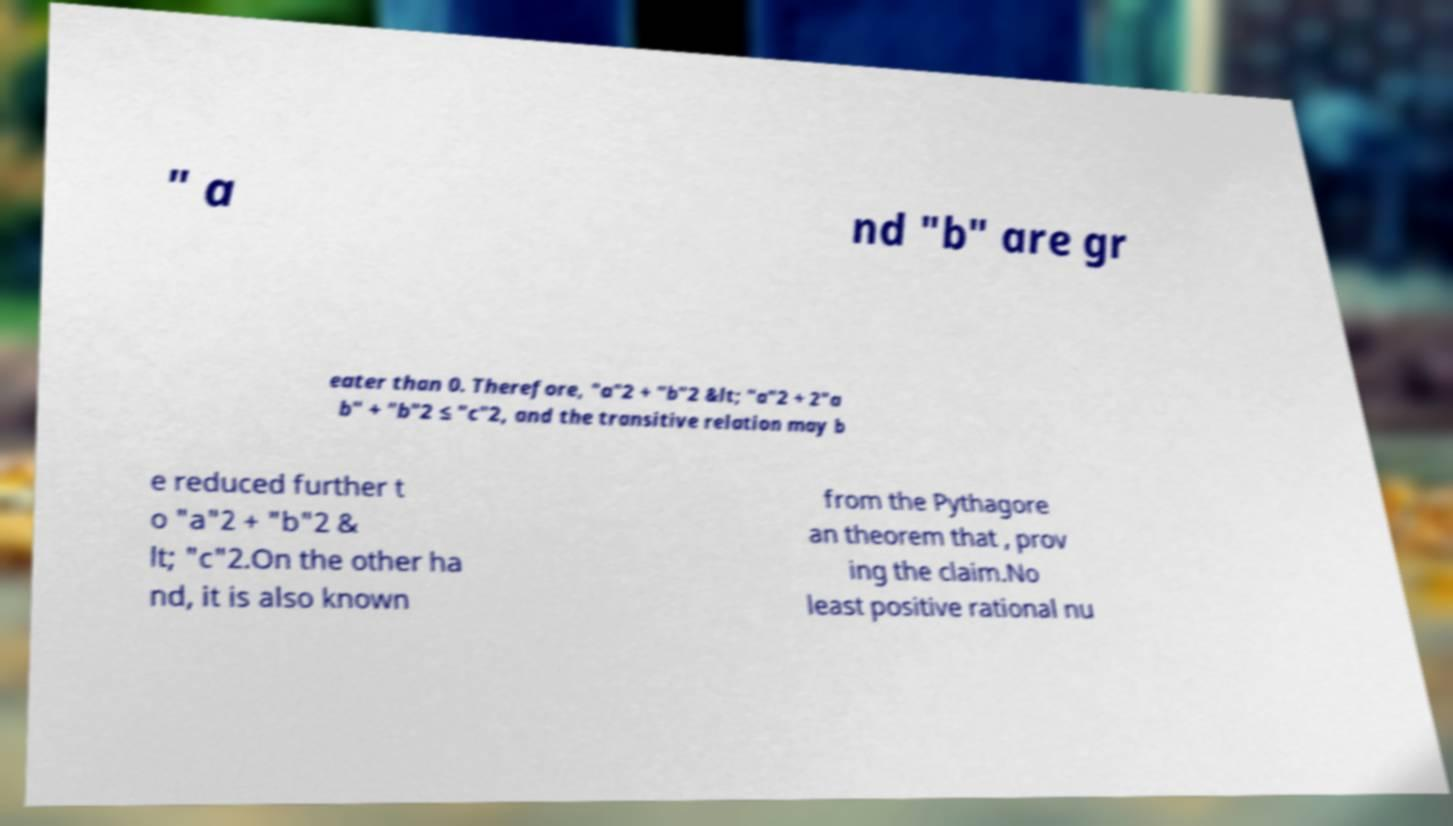For documentation purposes, I need the text within this image transcribed. Could you provide that? " a nd "b" are gr eater than 0. Therefore, "a"2 + "b"2 &lt; "a"2 + 2"a b" + "b"2 ≤ "c"2, and the transitive relation may b e reduced further t o "a"2 + "b"2 & lt; "c"2.On the other ha nd, it is also known from the Pythagore an theorem that , prov ing the claim.No least positive rational nu 